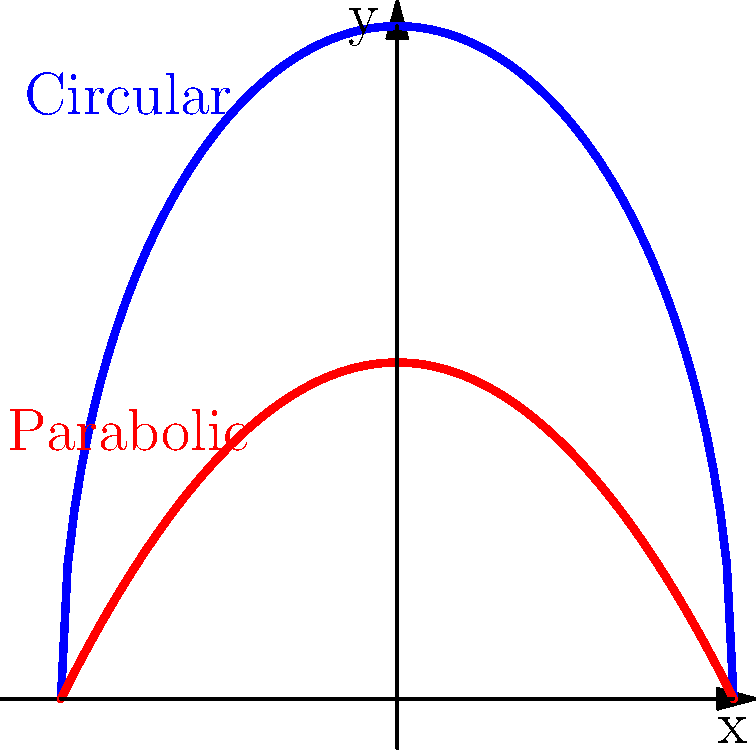As an editor reviewing a manuscript on fluid dynamics, you encounter a section discussing velocity profiles in pipes. The author claims that the velocity profile for laminar flow in a circular pipe is parabolic, while in a square pipe it's more flattened. Based on the graph shown, which curve represents the velocity profile for a circular pipe, and why is this shape significant for fluid flow analysis? To answer this question, let's break down the information and analyze the graph:

1. The graph shows two curves: a blue semicircle and a red parabola.

2. For laminar flow in a circular pipe:
   - The velocity profile is parabolic due to the no-slip condition at the walls and maximum velocity at the center.
   - This profile is described by the equation: $v(r) = v_{max}(1 - \frac{r^2}{R^2})$, where $r$ is the radial distance from the center and $R$ is the pipe radius.

3. The blue curve in the graph is semicircular, not parabolic. This shape is more flattened compared to the red parabolic curve.

4. The flattened profile (blue curve) is characteristic of flow in non-circular pipes, such as square pipes, due to the presence of secondary flows in the corners.

5. The parabolic profile (red curve) matches the expected velocity distribution for laminar flow in a circular pipe.

6. The parabolic shape is significant because:
   - It allows for easier calculation of flow rate and shear stress.
   - It indicates fully developed laminar flow, which is important for many engineering applications.
   - It provides a basis for comparison with other pipe shapes and flow conditions.

Therefore, the red parabolic curve represents the velocity profile for a circular pipe.
Answer: The red parabolic curve represents the circular pipe velocity profile, significant for its predictable flow characteristics and ease of analysis in fluid dynamics. 